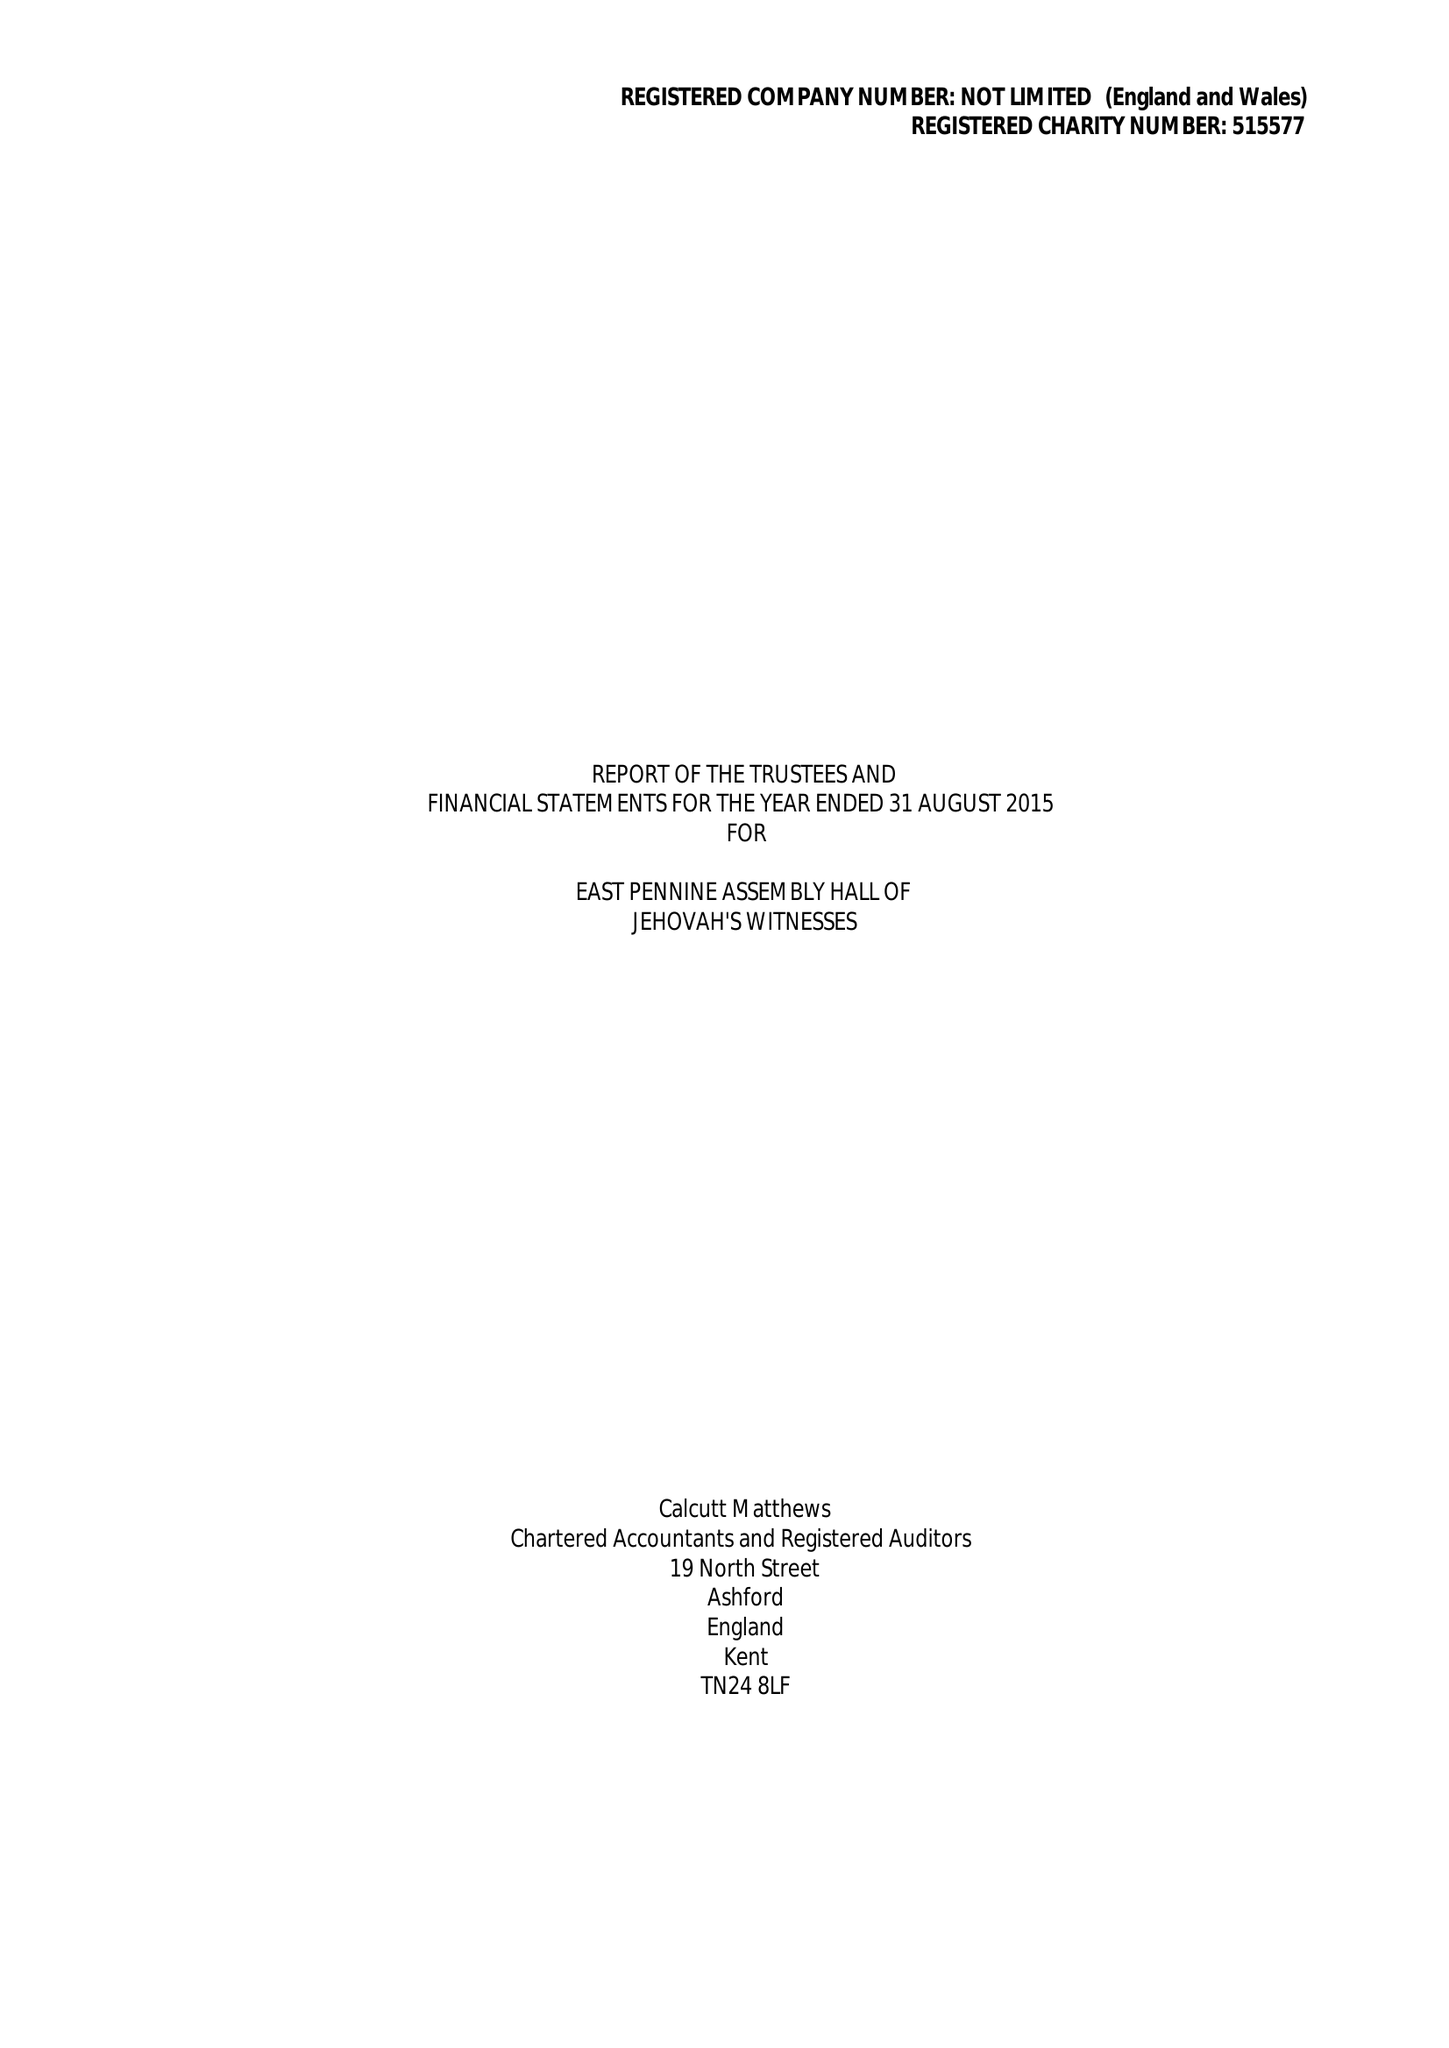What is the value for the report_date?
Answer the question using a single word or phrase. 2015-08-31 